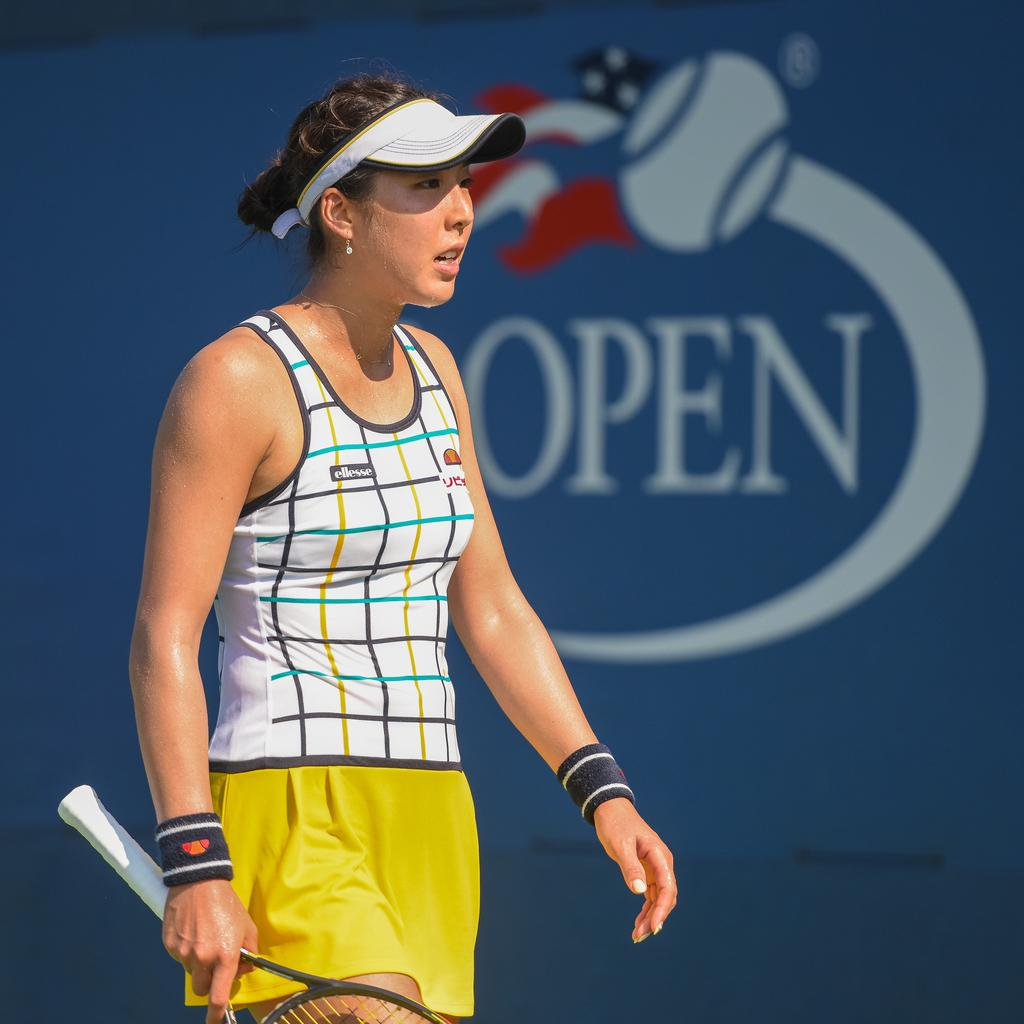Who is present in the image? There is a woman in the image. What is the woman holding in her hand? The woman is holding a racket in her hand. What is the woman wearing on her head? The woman is wearing a cap. What can be seen in the background of the image? There is a banner in the background of the image. What is written or depicted on the banner? The banner has some text on it and a picture of a ball. Can you tell me how many toes the woman is biting in the image? There is no indication in the image that the woman is biting her toes or anyone else's toes. 